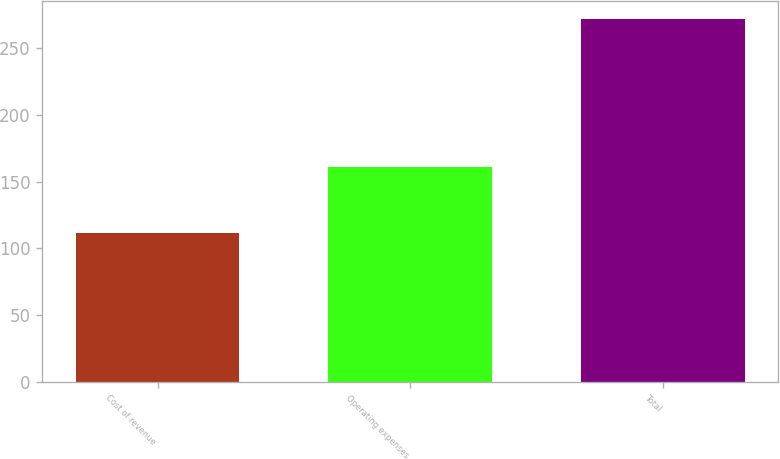<chart> <loc_0><loc_0><loc_500><loc_500><bar_chart><fcel>Cost of revenue<fcel>Operating expenses<fcel>Total<nl><fcel>111.2<fcel>160.9<fcel>272.1<nl></chart> 